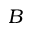Convert formula to latex. <formula><loc_0><loc_0><loc_500><loc_500>B</formula> 